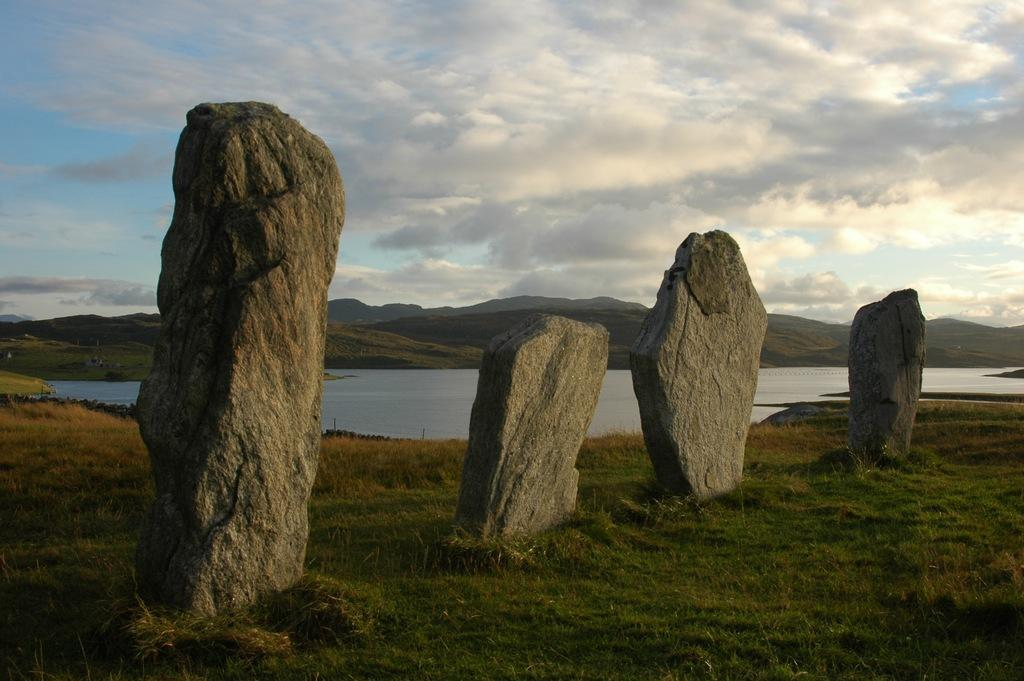What architectural features are present in the image? There are pillars in the image. What type of vegetation can be seen in the background of the image? The background of the image includes green grass. What natural feature is visible in the image? There is water visible in the image. What type of landscape can be seen in the distance? There are mountains in the background of the image. What is the color of the sky in the image? The sky is visible in the image, with colors of white and blue. What type of sign can be seen in the alley in the image? There is no alley or sign present in the image. 